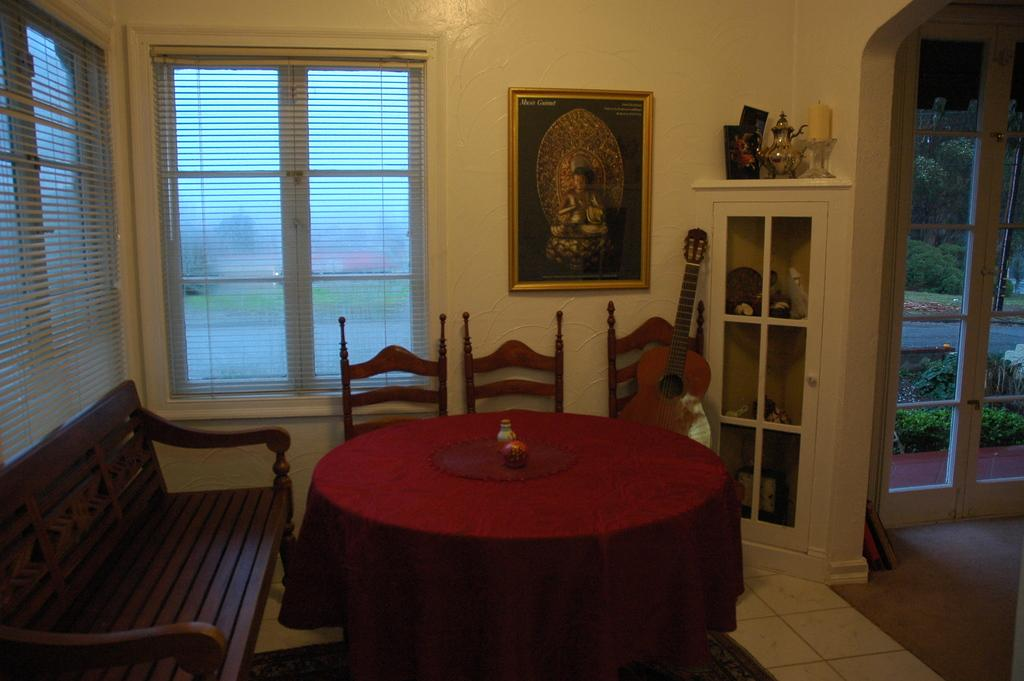What is the color of the wall in the image? The wall in the image is yellow. What can be seen on the wall? There is a window and a photo frame on the wall in the image. What type of furniture is present in the image? There are shelves, chairs, and a table in the image. Can you hear the nose crying in the image? There is no nose or crying sound present in the image. 